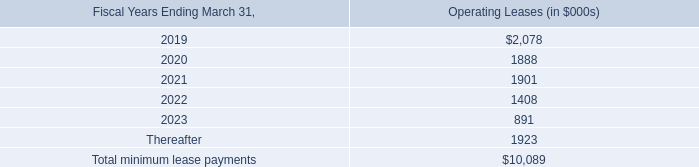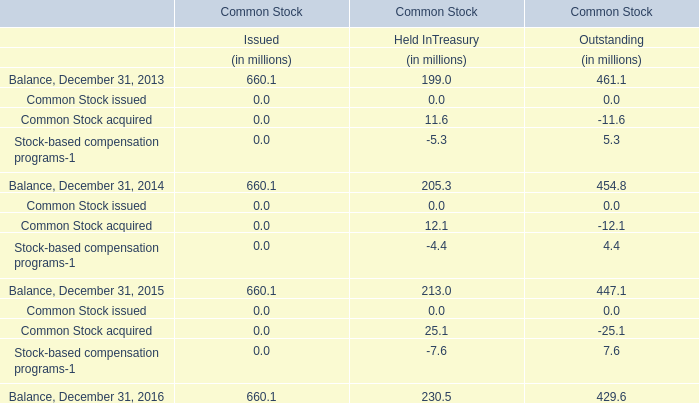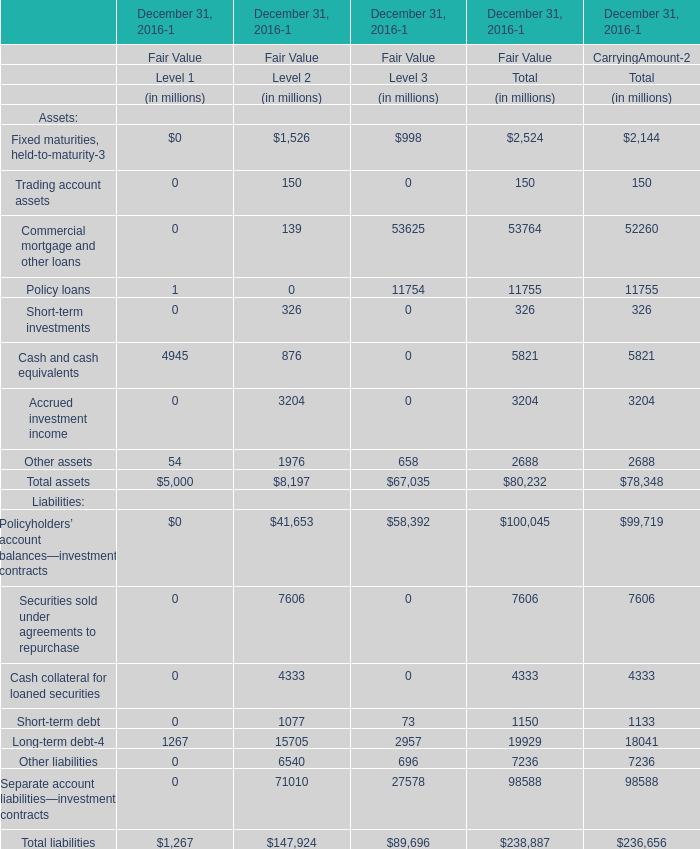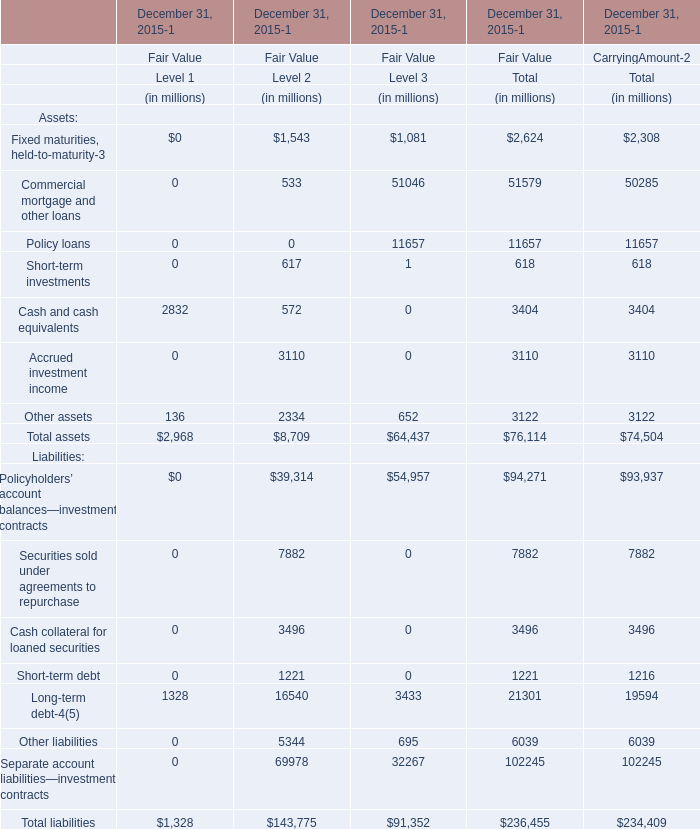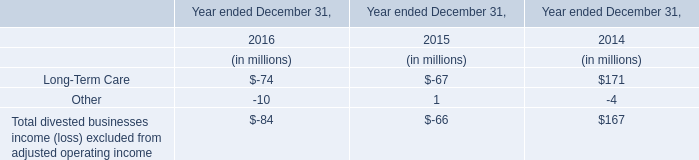What's the total value of all asset that are in the range of 3000 and 10000 in 2015? (in million) 
Computations: ((3404 + 3110) + 3122)
Answer: 9636.0. 